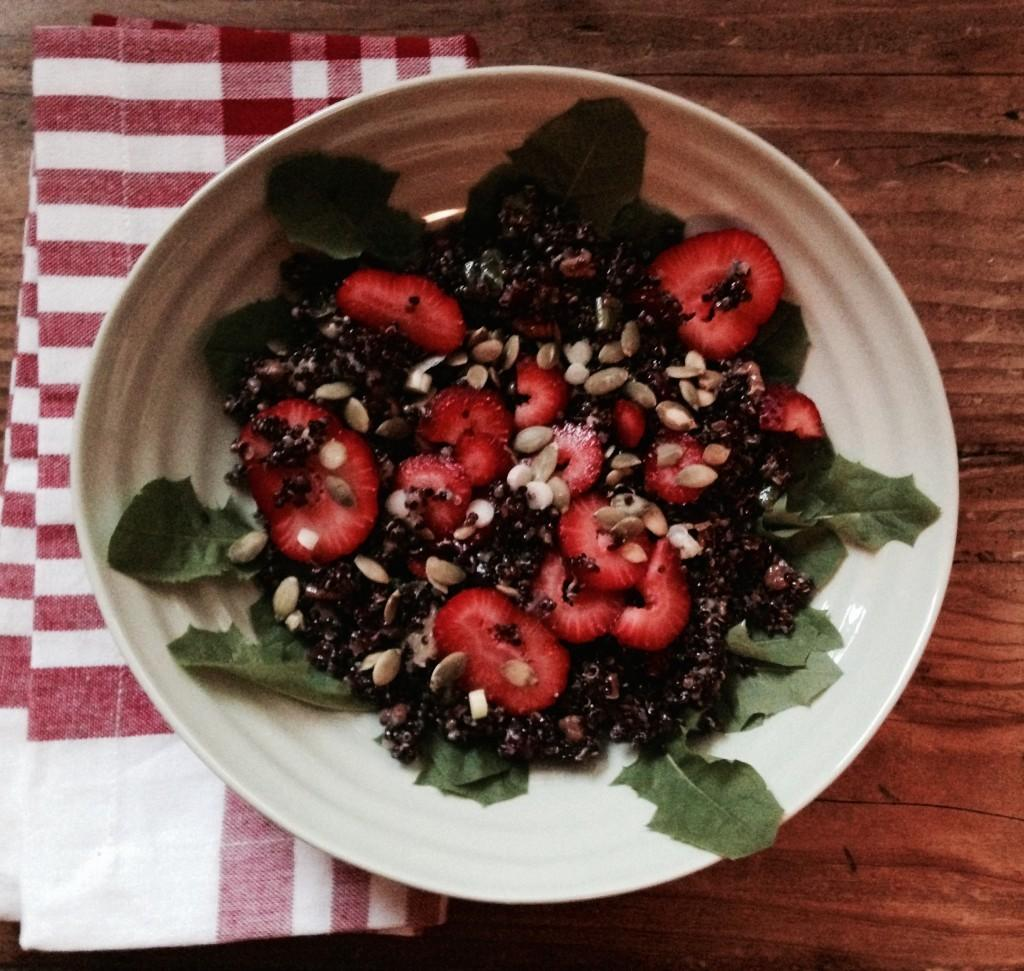What is in the bowl that is visible in the image? There is food in a bowl in the image. What type of food can be seen in the image? There are strawberries in the image. What else is present in the image besides the food? There are leaves and a cloth on the table in the image. How many pins are holding the strawberries in place in the image? There are no pins present in the image; the strawberries are not being held in place. 